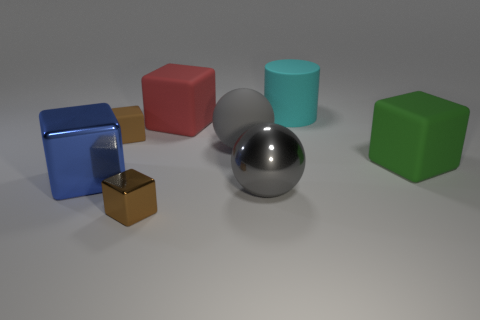How many brown cubes must be subtracted to get 1 brown cubes? 1 Subtract all red matte cubes. How many cubes are left? 4 Add 1 big red blocks. How many objects exist? 9 Subtract all green cubes. How many cubes are left? 4 Subtract 2 gray balls. How many objects are left? 6 Subtract all cylinders. How many objects are left? 7 Subtract 1 balls. How many balls are left? 1 Subtract all cyan cubes. Subtract all brown cylinders. How many cubes are left? 5 Subtract all brown cubes. How many purple cylinders are left? 0 Subtract all gray shiny things. Subtract all cylinders. How many objects are left? 6 